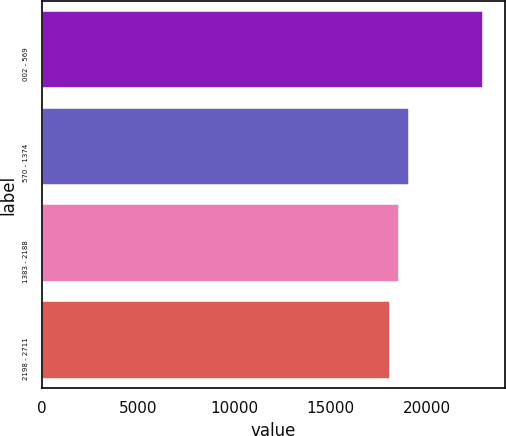Convert chart to OTSL. <chart><loc_0><loc_0><loc_500><loc_500><bar_chart><fcel>002 - 569<fcel>570 - 1374<fcel>1383 - 2188<fcel>2198 - 2711<nl><fcel>22937<fcel>19060.2<fcel>18575.6<fcel>18091<nl></chart> 